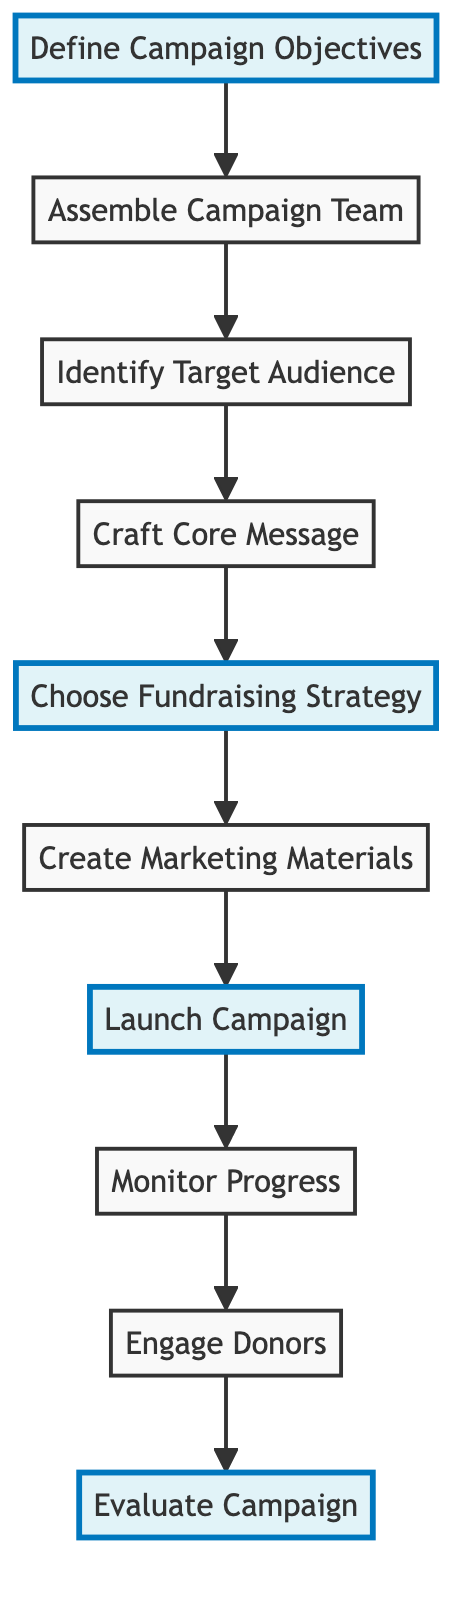What is the first step in the fundraising campaign? The diagram starts with the node labeled "Define Campaign Objectives," which indicates it is the first step in the process.
Answer: Define Campaign Objectives How many nodes are in the flowchart? By counting the elements shown in the diagram, there are ten distinct nodes representing various steps in the fundraising campaign.
Answer: 10 What is the last step in the fundraising campaign? The final node in the flowchart is labeled "Evaluate Campaign," which indicates it is the last step of the process.
Answer: Evaluate Campaign Which two nodes are directly connected to the node "Launch Campaign"? Following the flowchart, "Launch Campaign" leads to "Monitor Progress" and is preceded by "Create Marketing Materials"; hence, these two nodes are directly connected to it.
Answer: Monitor Progress, Create Marketing Materials What role comes after "Identify Target Audience"? According to the flow direction in the diagram, the step following "Identify Target Audience" is "Craft Core Message."
Answer: Craft Core Message What is the relationship between "Assemble Campaign Team" and "Engage Donors"? The flowchart indicates that "Assemble Campaign Team" is an earlier step, while "Engage Donors" comes later in the sequence, suggesting a sequential relationship between the two steps.
Answer: Sequential relationship Which node highlights the beginning of the campaign's implementation? In the diagram, "Launch Campaign" is one of the highlighted nodes, which represents the start of the actual implementation of the fundraising strategy.
Answer: Launch Campaign If you complete the "Craft Core Message," what is the next step? Upon completing "Craft Core Message," the flow indicates that the next step is "Choose Fundraising Strategy."
Answer: Choose Fundraising Strategy What are the highlighted steps in the diagram? The highlighted steps specifically identified in the flowchart are "Define Campaign Objectives," "Choose Fundraising Strategy," "Launch Campaign," and "Evaluate Campaign."
Answer: Define Campaign Objectives, Choose Fundraising Strategy, Launch Campaign, Evaluate Campaign 